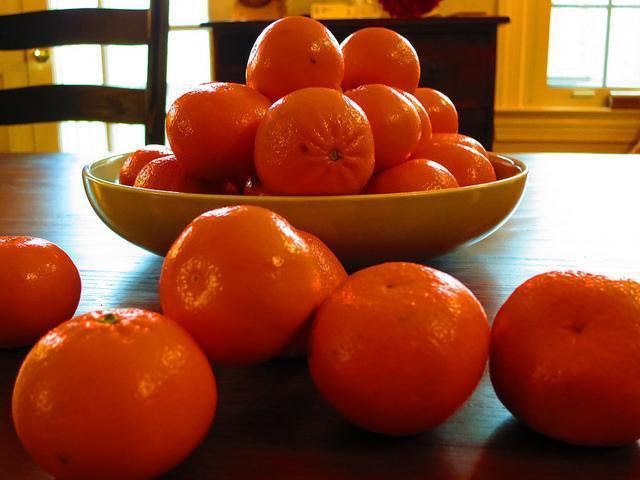How many of the tangerines are not in the bowl?
Give a very brief answer. 6. How many chairs do you see?
Give a very brief answer. 1. How many oranges are there?
Give a very brief answer. 7. How many forks are on the table?
Give a very brief answer. 0. 